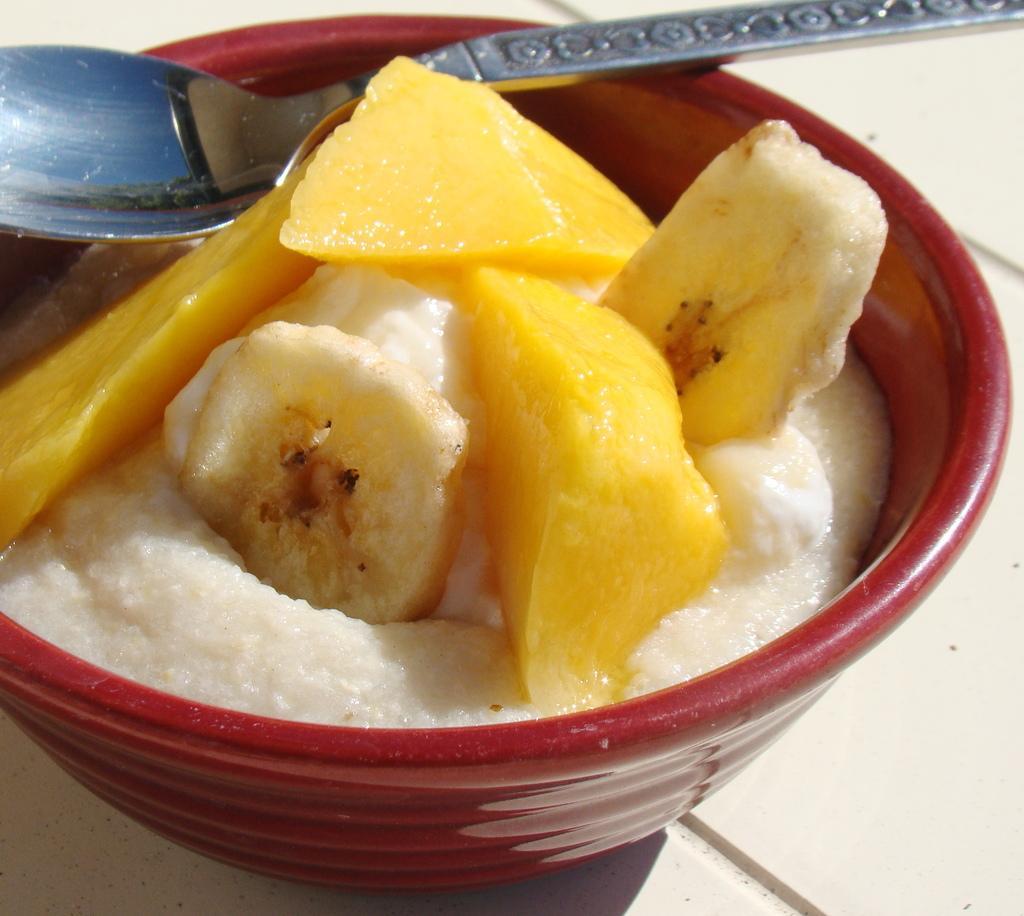How would you summarize this image in a sentence or two? In the foreground of this image, there is a red bowl with fruits and white color creamy like substance is in it. There is a spoon on the bowl and the bowl is placed on a white surface. 